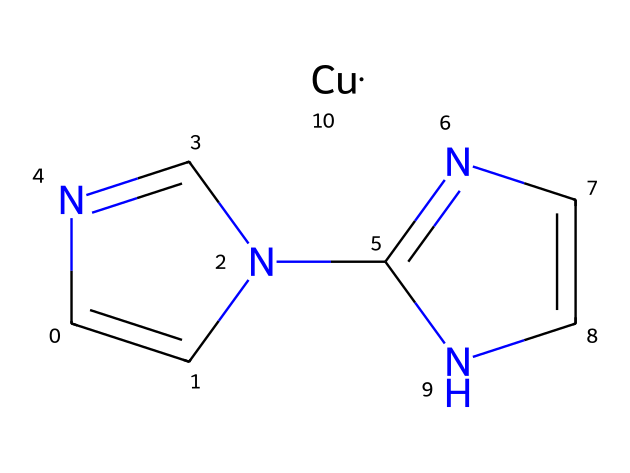What is the total number of atoms in this compound? By examining the provided SMILES structure, we can count the individual atoms represented in the notation. The compound contains 8 carbon atoms (C), 6 nitrogen atoms (N), and 1 copper atom (Cu), adding up to a total of 15 atoms.
Answer: 15 How many nitrogen atoms are present? The SMILES reveals that there are a total of 6 nitrogen atoms in the structure, as explicitly indicated by the "N" characters in the notation.
Answer: 6 What type of metal is coordinated in this complex? The SMILES notation ends with "[Cu]", indicating the presence of copper as the coordinated metal in this carbene complex.
Answer: copper Which type of ligand is forming the carbene in this compound? The structure shows a C=N bond, which suggests that the compound includes an imine-type ligand that can stabilize the carbene form. Carbene is typically represented as a divalent carbon atom with a lone pair, here integrated into a nitrogen-containing framework.
Answer: imine Is there a cyclic structure present in the complex? Looking at the fragment "C1=CN(C=N1)", there is a ring structure implied, indicated by the '1' which denotes the start and end of a ring. Thus, it confirms the presence of a cyclical portion in the complex.
Answer: yes What characteristic does carbene contribute to pest control effectiveness? Carbenes are known for their high reactivity, which allows them to effectively interact with organic materials or pests in pest control applications. This reactivity makes them potent for disrupting biological processes in pests.
Answer: high reactivity 